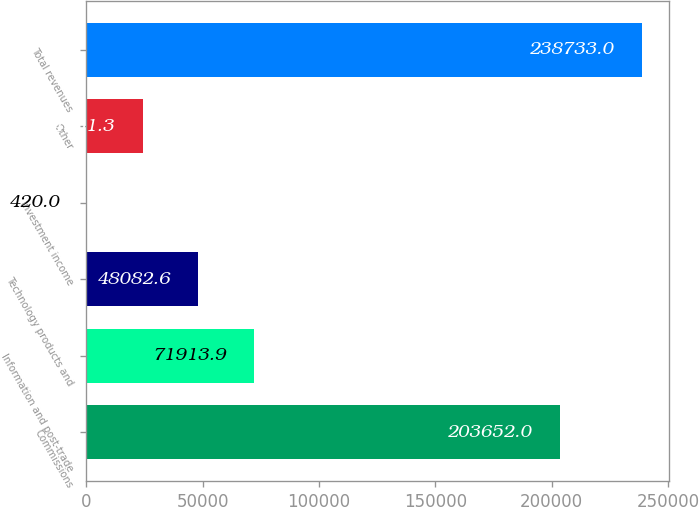<chart> <loc_0><loc_0><loc_500><loc_500><bar_chart><fcel>Commissions<fcel>Information and post-trade<fcel>Technology products and<fcel>Investment income<fcel>Other<fcel>Total revenues<nl><fcel>203652<fcel>71913.9<fcel>48082.6<fcel>420<fcel>24251.3<fcel>238733<nl></chart> 